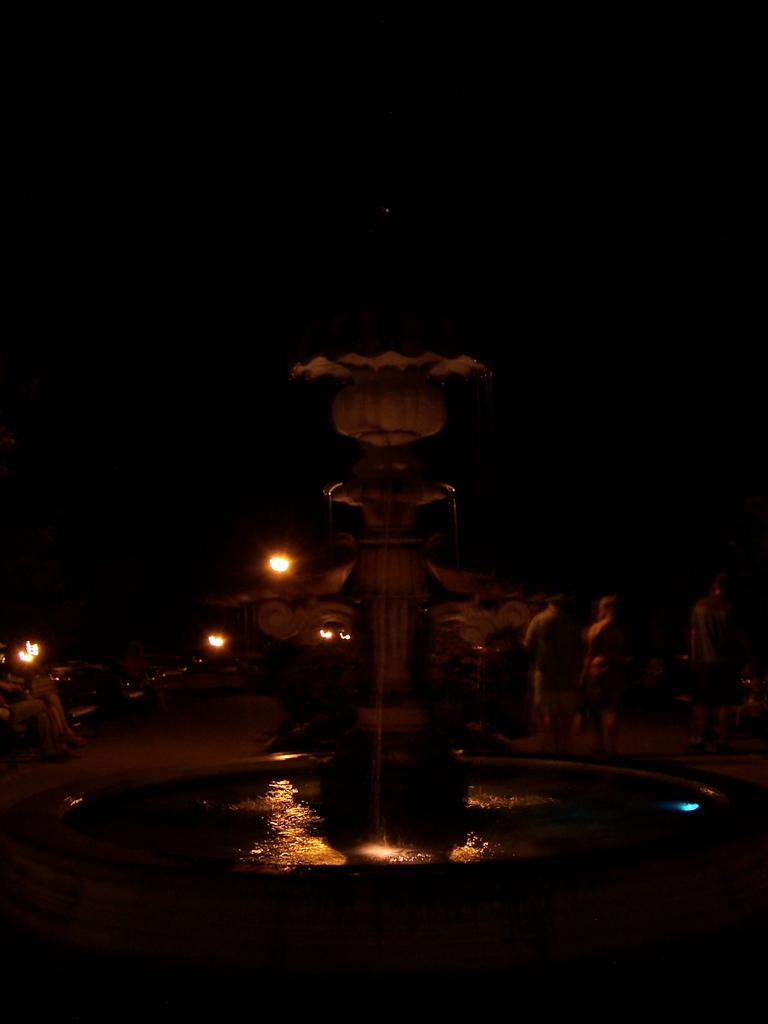What is the main subject in the center of the image? There is a fountain in the center of the image. What can be seen in the background of the image? There are people and lights in the background of the image. What time of day does the image appear to be captured? The image appears to be captured during night time. What type of nut is being used to power the fountain in the image? There is no nut present in the image, and the fountain is not powered by a nut. 